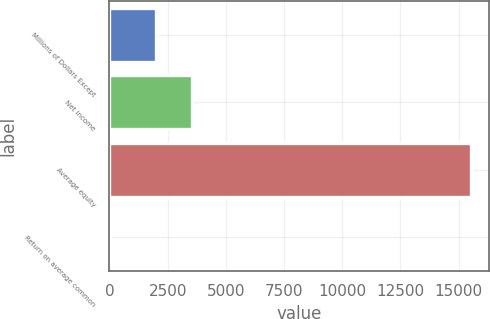<chart> <loc_0><loc_0><loc_500><loc_500><bar_chart><fcel>Millions of Dollars Except<fcel>Net income<fcel>Average equity<fcel>Return on average common<nl><fcel>2008<fcel>3558.09<fcel>15516<fcel>15.1<nl></chart> 